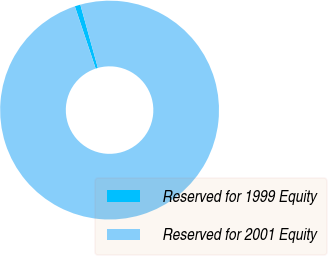Convert chart to OTSL. <chart><loc_0><loc_0><loc_500><loc_500><pie_chart><fcel>Reserved for 1999 Equity<fcel>Reserved for 2001 Equity<nl><fcel>0.84%<fcel>99.16%<nl></chart> 